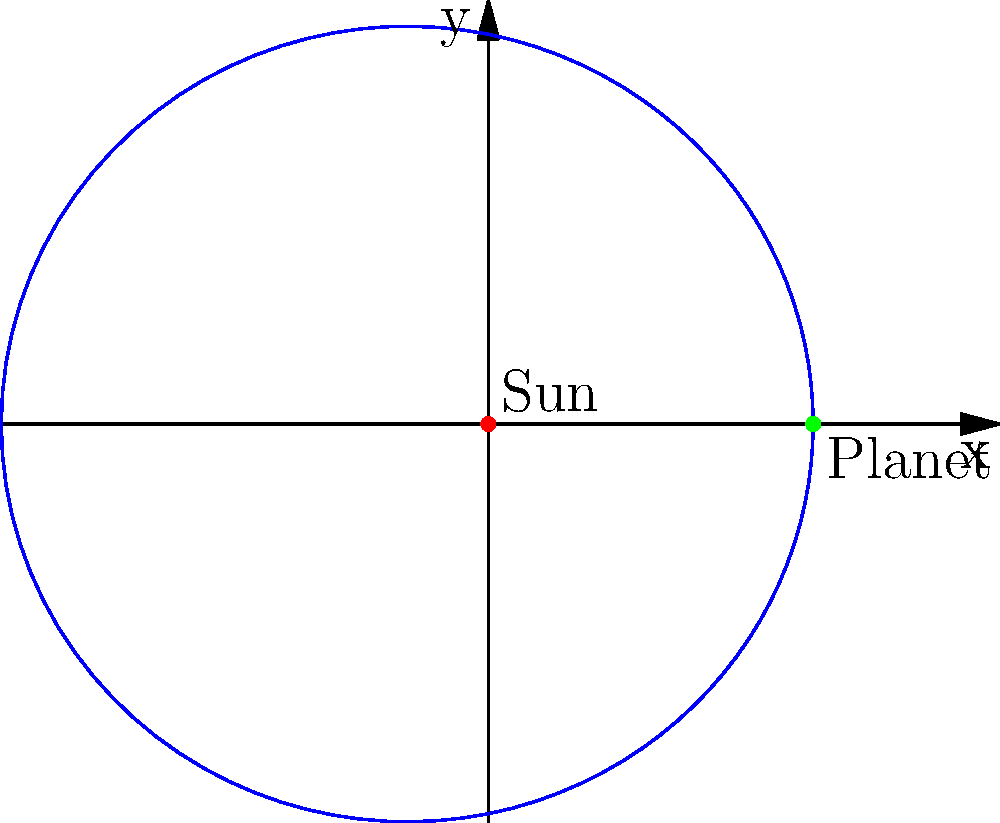As a science journalist interviewing an engineer about planetary orbits, you come across a polar equation model: $r = \frac{1}{1 + e\cos(\theta)}$, where $e$ represents the eccentricity. If a planet's orbit has an eccentricity of 0.2, what is the planet's closest approach distance to the sun (perihelion) in terms of the semi-latus rectum? To solve this problem, let's follow these steps:

1) The given polar equation for a planetary orbit is:
   $r = \frac{1}{1 + e\cos(\theta)}$

2) We're told that the eccentricity $e = 0.2$

3) The perihelion occurs when the planet is closest to the sun. This happens when $\cos(\theta) = 1$, or when $\theta = 0$.

4) Let's substitute these values into our equation:
   $r_{perihelion} = \frac{1}{1 + 0.2\cos(0)} = \frac{1}{1 + 0.2(1)} = \frac{1}{1.2}$

5) The semi-latus rectum (let's call it $p$) is defined as $p = a(1-e^2)$, where $a$ is the semi-major axis. In the polar equation, $p$ is actually the denominator.

6) So, we can express our answer in terms of $p$:
   $r_{perihelion} = \frac{p}{1 + e} = \frac{p}{1.2}$

Therefore, the planet's closest approach to the sun is $\frac{5}{6}$ or $0.833$ times the semi-latus rectum.
Answer: $\frac{5}{6}p$ or $0.833p$ 